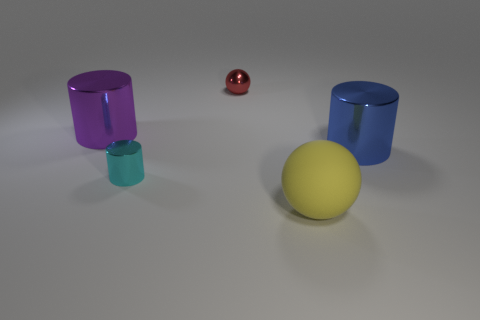Subtract all purple cylinders. How many cylinders are left? 2 Add 4 tiny red metallic cylinders. How many objects exist? 9 Subtract 2 cylinders. How many cylinders are left? 1 Subtract all yellow spheres. How many spheres are left? 1 Subtract all cylinders. How many objects are left? 2 Subtract all gray spheres. Subtract all red blocks. How many spheres are left? 2 Subtract all large gray spheres. Subtract all small things. How many objects are left? 3 Add 5 big matte objects. How many big matte objects are left? 6 Add 4 purple shiny things. How many purple shiny things exist? 5 Subtract 0 red cubes. How many objects are left? 5 